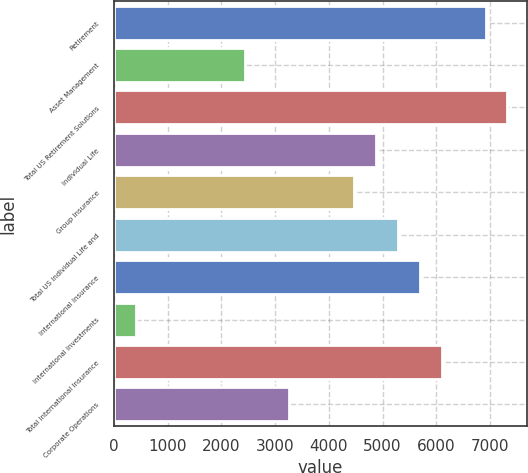<chart> <loc_0><loc_0><loc_500><loc_500><bar_chart><fcel>Retirement<fcel>Asset Management<fcel>Total US Retirement Solutions<fcel>Individual Life<fcel>Group Insurance<fcel>Total US Individual Life and<fcel>International Insurance<fcel>International Investments<fcel>Total International Insurance<fcel>Corporate Operations<nl><fcel>6916.99<fcel>2441.64<fcel>7323.84<fcel>4882.74<fcel>4475.89<fcel>5289.59<fcel>5696.44<fcel>407.39<fcel>6103.29<fcel>3255.34<nl></chart> 